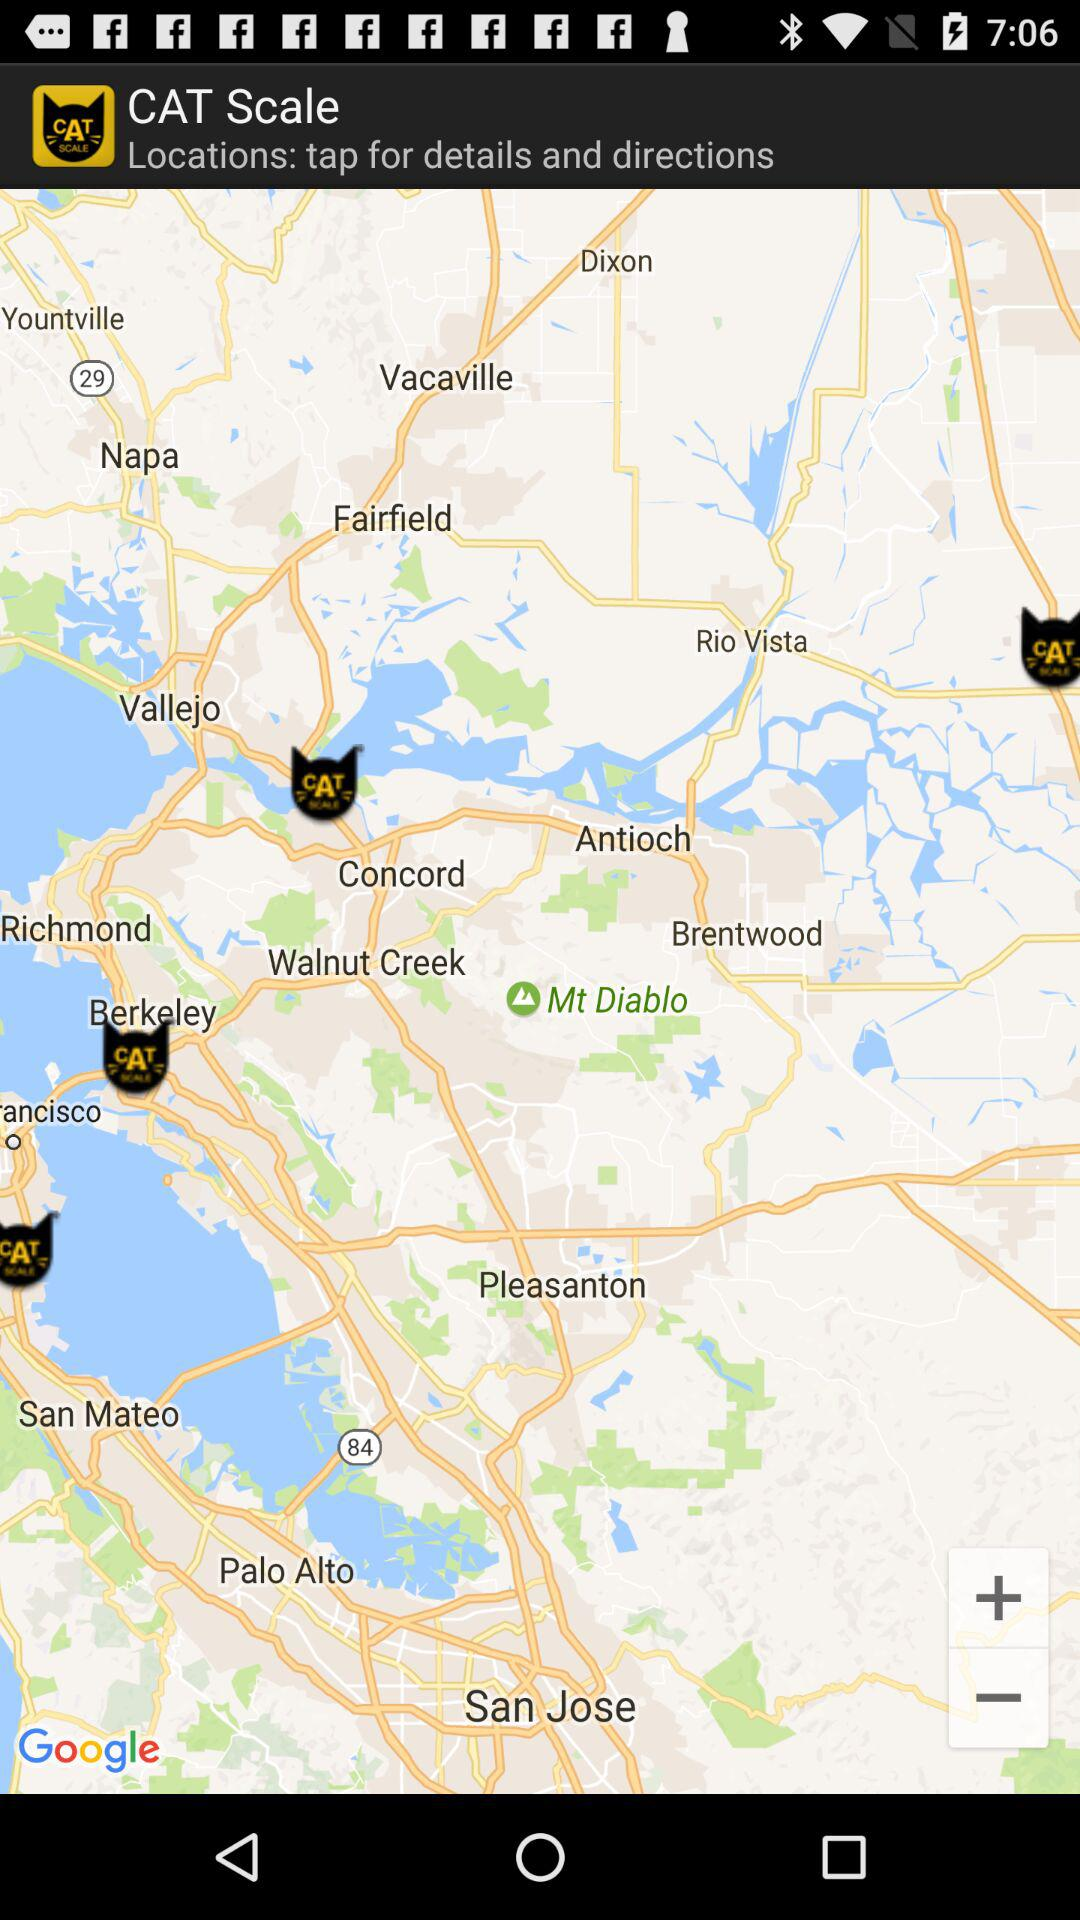What is the postal code? The postal code is 94101. 